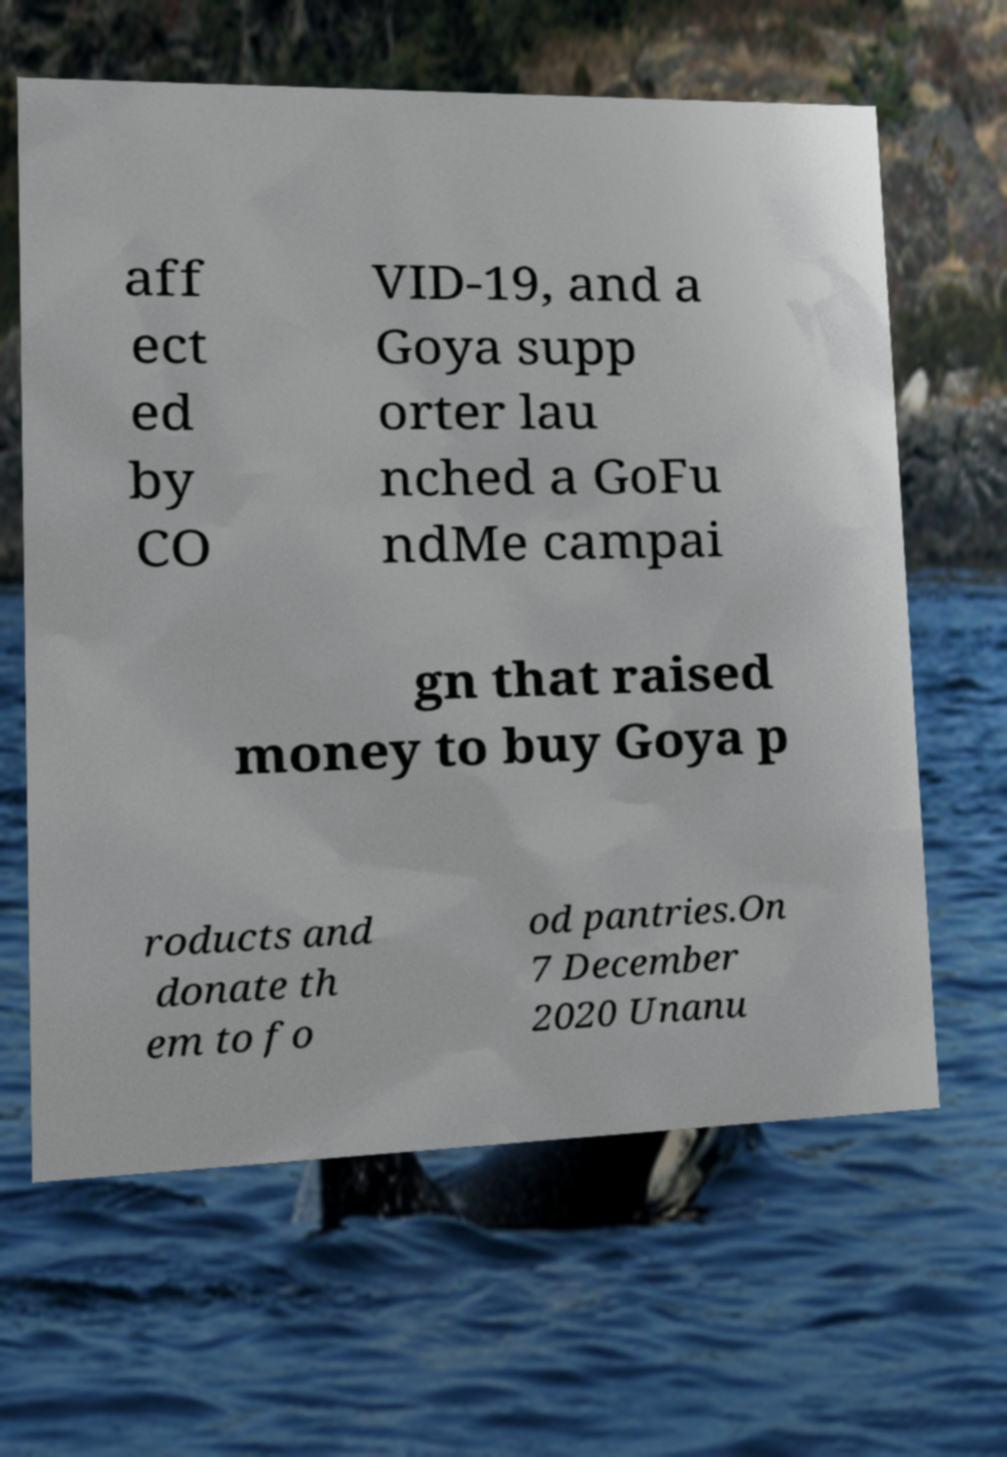Could you assist in decoding the text presented in this image and type it out clearly? aff ect ed by CO VID-19, and a Goya supp orter lau nched a GoFu ndMe campai gn that raised money to buy Goya p roducts and donate th em to fo od pantries.On 7 December 2020 Unanu 